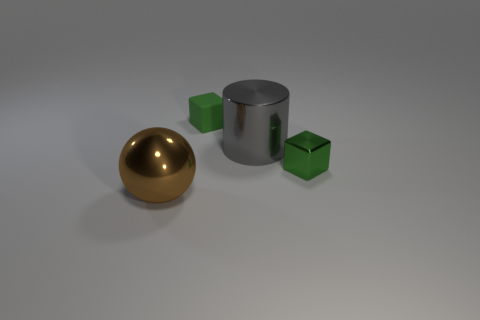Are there the same number of large gray shiny objects left of the large brown metallic ball and tiny green rubber things behind the small green rubber object?
Ensure brevity in your answer.  Yes. Are there any other things that are the same size as the metallic block?
Provide a short and direct response. Yes. What is the color of the big object that is the same material as the brown sphere?
Ensure brevity in your answer.  Gray. Is the material of the big ball the same as the tiny green object left of the large gray metal object?
Offer a very short reply. No. The metallic object that is in front of the large gray shiny object and on the right side of the big brown ball is what color?
Provide a short and direct response. Green. How many cylinders are either tiny objects or brown metallic objects?
Provide a succinct answer. 0. There is a big gray metal object; does it have the same shape as the big metal thing in front of the small green metal object?
Make the answer very short. No. What size is the thing that is in front of the gray cylinder and to the left of the large gray metal thing?
Your answer should be compact. Large. There is a brown metallic thing; what shape is it?
Give a very brief answer. Sphere. There is a metal thing to the right of the gray cylinder; is there a small green rubber thing behind it?
Give a very brief answer. Yes. 